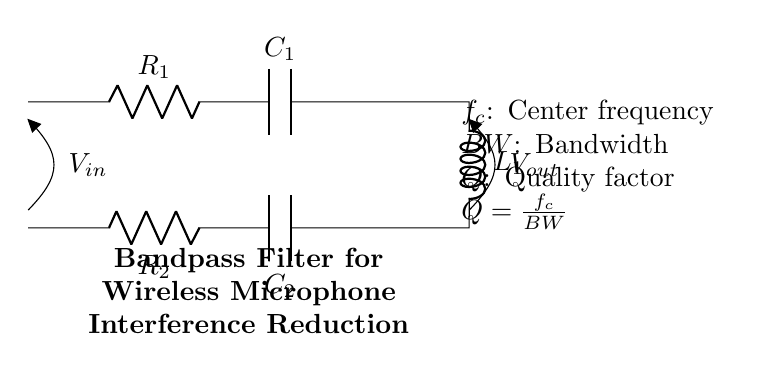What are the components used in this filter circuit? The circuit consists of two resistors, two capacitors, and one inductor. This is deduced by counting the components labeled R, C, and L in the diagram.
Answer: Two resistors, two capacitors, one inductor What is the function of the center frequency in the circuit? The center frequency determines the frequency at which the filter allows signals to pass with maximum gain or attenuation. This is a key characteristic defining the performance of a bandpass filter.
Answer: Maximum gain frequency How many resistors are in the circuit? The diagram shows two components labeled as resistors, indicating the total amount present in the circuit.
Answer: Two What is the quality factor of the filter? The quality factor is calculated using the formula Q equals the center frequency divided by the bandwidth. Knowing that both the center frequency and bandwidth are parameters illustrated, one can derive the quality factor specifically for this filter circuit.
Answer: Calculation needed What happens to signals outside the bandwidth of the filter? Signals at frequencies outside the set bandwidth are significantly attenuated, which means they are reduced in magnitude. This characteristic of bandpass filters allows them to selectively filter out unwanted frequencies effectively.
Answer: Attenuated What would increase the bandwidth of this filter? In this circuit design, decreasing the quality factor will result in an increased bandwidth, as the two are inversely related. Modifying the resistor or capacitor values can influence the quality factor and subsequently the bandwidth of the filter.
Answer: Decrease quality factor 